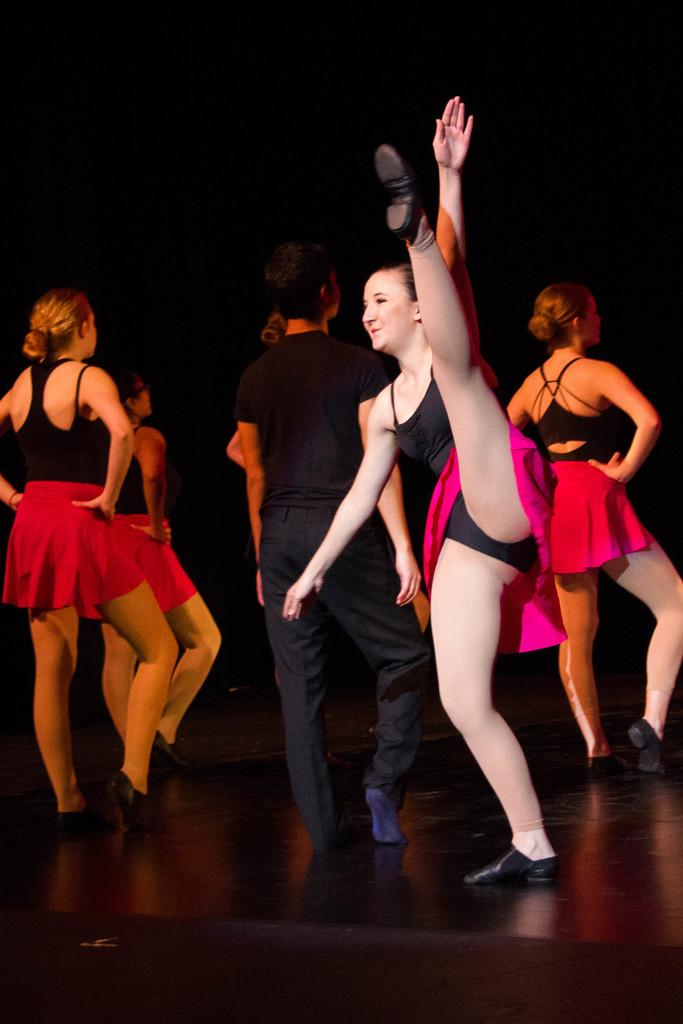What are the people in the image doing? The people in the image are dancing on the stage. What can be seen behind the people on the stage? The background is black. How many rays are visible on the stage in the image? There are no rays visible on the stage in the image. What type of tongue is being used by the people dancing on the stage? There is no mention of a tongue in the image; the people are dancing. 